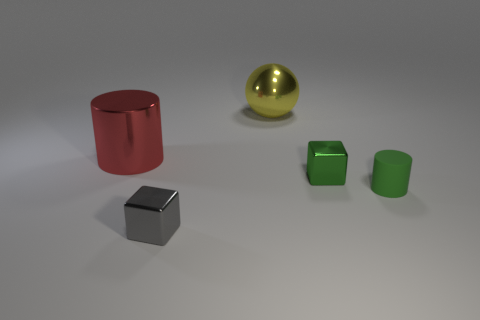Add 5 small green blocks. How many objects exist? 10 Subtract all balls. How many objects are left? 4 Subtract all metallic balls. Subtract all spheres. How many objects are left? 3 Add 2 rubber objects. How many rubber objects are left? 3 Add 4 large red shiny objects. How many large red shiny objects exist? 5 Subtract 0 purple cylinders. How many objects are left? 5 